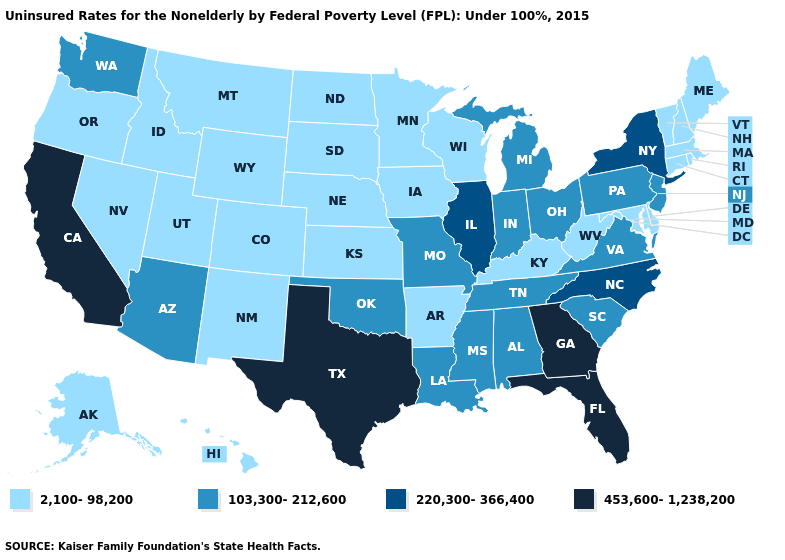Name the states that have a value in the range 220,300-366,400?
Give a very brief answer. Illinois, New York, North Carolina. What is the value of Wisconsin?
Answer briefly. 2,100-98,200. Name the states that have a value in the range 453,600-1,238,200?
Concise answer only. California, Florida, Georgia, Texas. Name the states that have a value in the range 220,300-366,400?
Quick response, please. Illinois, New York, North Carolina. Which states have the lowest value in the USA?
Be succinct. Alaska, Arkansas, Colorado, Connecticut, Delaware, Hawaii, Idaho, Iowa, Kansas, Kentucky, Maine, Maryland, Massachusetts, Minnesota, Montana, Nebraska, Nevada, New Hampshire, New Mexico, North Dakota, Oregon, Rhode Island, South Dakota, Utah, Vermont, West Virginia, Wisconsin, Wyoming. Name the states that have a value in the range 2,100-98,200?
Quick response, please. Alaska, Arkansas, Colorado, Connecticut, Delaware, Hawaii, Idaho, Iowa, Kansas, Kentucky, Maine, Maryland, Massachusetts, Minnesota, Montana, Nebraska, Nevada, New Hampshire, New Mexico, North Dakota, Oregon, Rhode Island, South Dakota, Utah, Vermont, West Virginia, Wisconsin, Wyoming. Name the states that have a value in the range 103,300-212,600?
Give a very brief answer. Alabama, Arizona, Indiana, Louisiana, Michigan, Mississippi, Missouri, New Jersey, Ohio, Oklahoma, Pennsylvania, South Carolina, Tennessee, Virginia, Washington. Name the states that have a value in the range 2,100-98,200?
Give a very brief answer. Alaska, Arkansas, Colorado, Connecticut, Delaware, Hawaii, Idaho, Iowa, Kansas, Kentucky, Maine, Maryland, Massachusetts, Minnesota, Montana, Nebraska, Nevada, New Hampshire, New Mexico, North Dakota, Oregon, Rhode Island, South Dakota, Utah, Vermont, West Virginia, Wisconsin, Wyoming. Does Colorado have the lowest value in the West?
Keep it brief. Yes. What is the value of Hawaii?
Give a very brief answer. 2,100-98,200. Which states hav the highest value in the South?
Concise answer only. Florida, Georgia, Texas. What is the value of Florida?
Be succinct. 453,600-1,238,200. What is the highest value in the Northeast ?
Quick response, please. 220,300-366,400. Does the map have missing data?
Short answer required. No. How many symbols are there in the legend?
Short answer required. 4. 